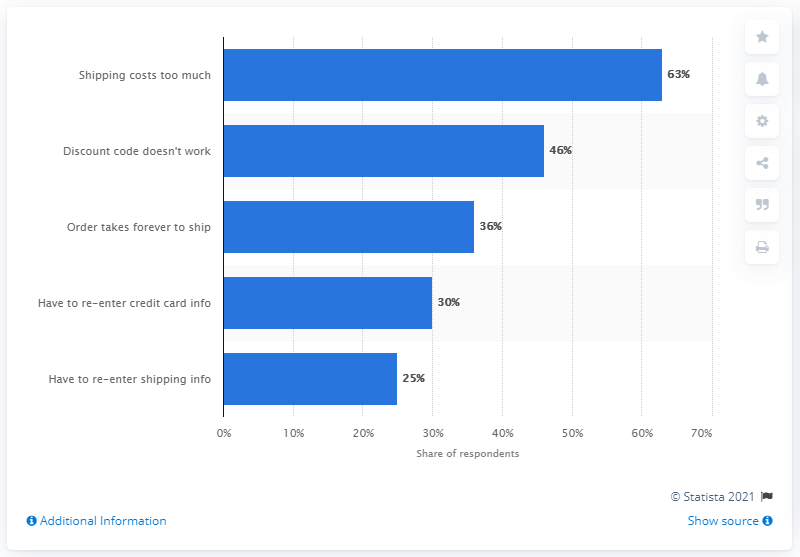List a handful of essential elements in this visual. The combined percentage of the two lowest reasons given was 55%. The second most common reason why digital shoppers abandon their carts is because the discount code they were using did not work. 